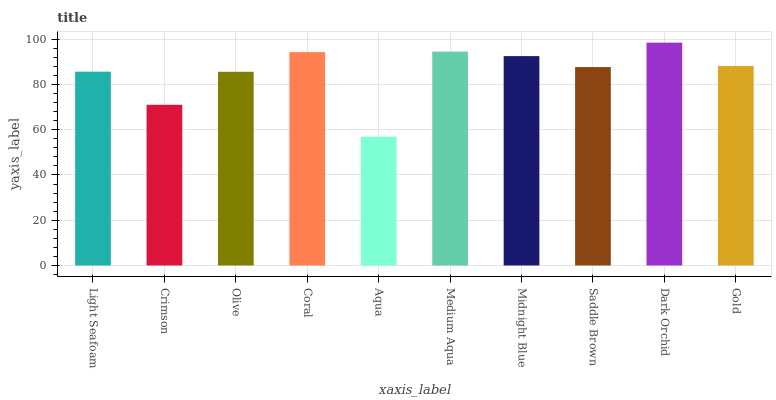Is Crimson the minimum?
Answer yes or no. No. Is Crimson the maximum?
Answer yes or no. No. Is Light Seafoam greater than Crimson?
Answer yes or no. Yes. Is Crimson less than Light Seafoam?
Answer yes or no. Yes. Is Crimson greater than Light Seafoam?
Answer yes or no. No. Is Light Seafoam less than Crimson?
Answer yes or no. No. Is Gold the high median?
Answer yes or no. Yes. Is Saddle Brown the low median?
Answer yes or no. Yes. Is Dark Orchid the high median?
Answer yes or no. No. Is Aqua the low median?
Answer yes or no. No. 